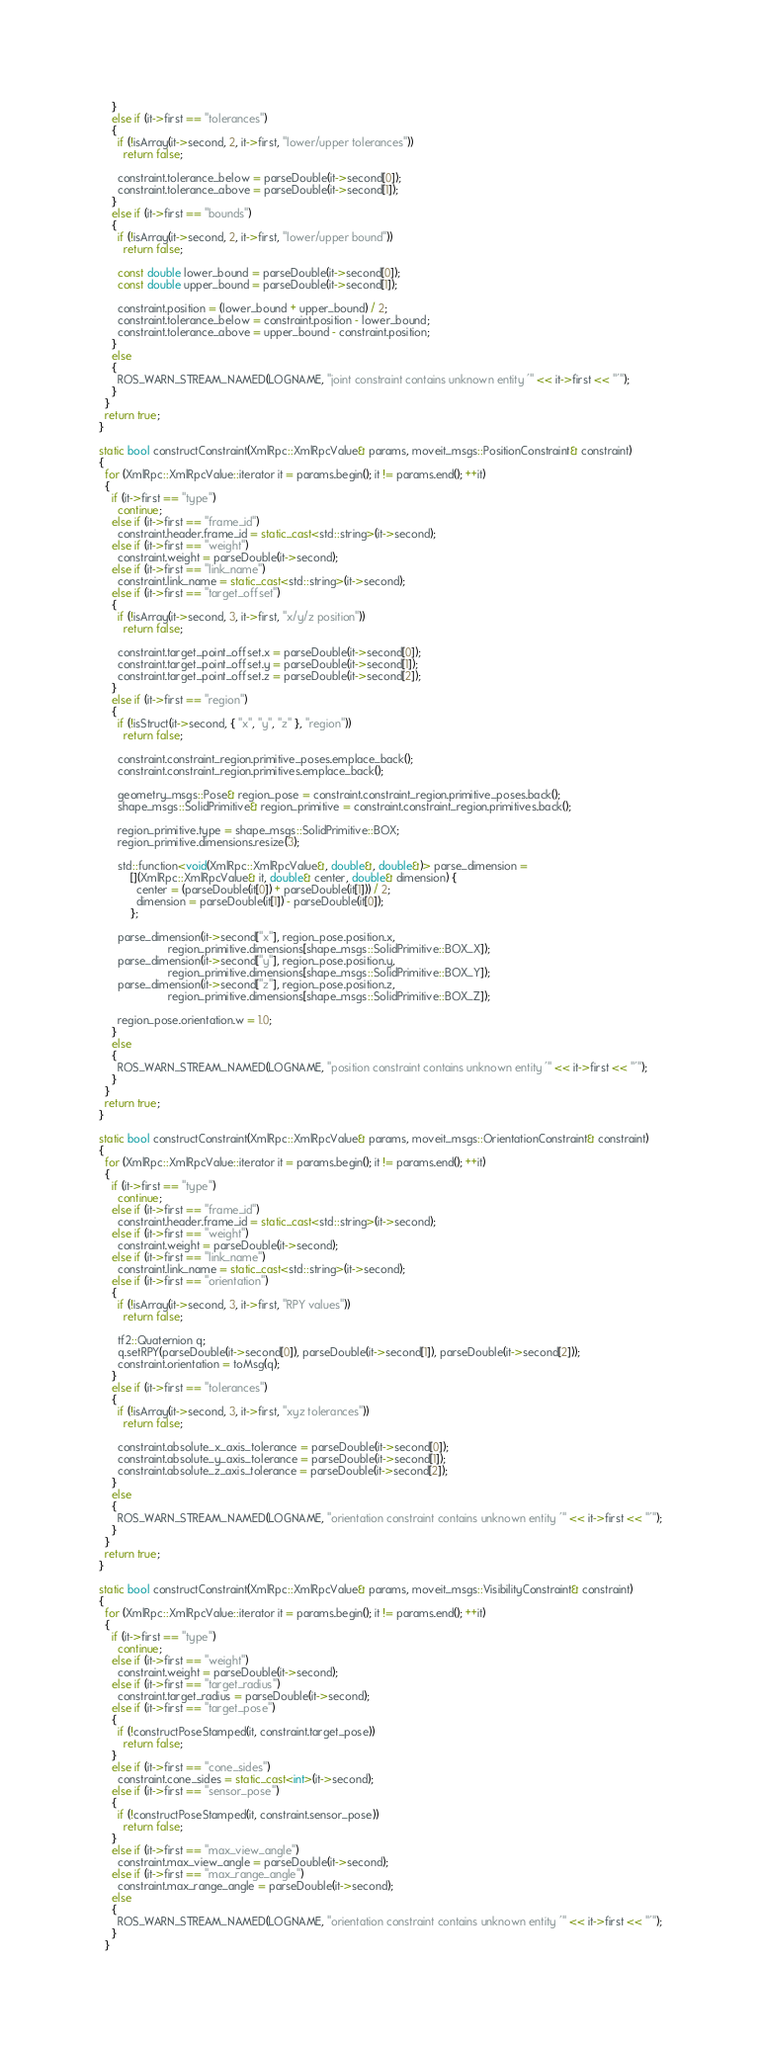Convert code to text. <code><loc_0><loc_0><loc_500><loc_500><_C++_>    }
    else if (it->first == "tolerances")
    {
      if (!isArray(it->second, 2, it->first, "lower/upper tolerances"))
        return false;

      constraint.tolerance_below = parseDouble(it->second[0]);
      constraint.tolerance_above = parseDouble(it->second[1]);
    }
    else if (it->first == "bounds")
    {
      if (!isArray(it->second, 2, it->first, "lower/upper bound"))
        return false;

      const double lower_bound = parseDouble(it->second[0]);
      const double upper_bound = parseDouble(it->second[1]);

      constraint.position = (lower_bound + upper_bound) / 2;
      constraint.tolerance_below = constraint.position - lower_bound;
      constraint.tolerance_above = upper_bound - constraint.position;
    }
    else
    {
      ROS_WARN_STREAM_NAMED(LOGNAME, "joint constraint contains unknown entity '" << it->first << "'");
    }
  }
  return true;
}

static bool constructConstraint(XmlRpc::XmlRpcValue& params, moveit_msgs::PositionConstraint& constraint)
{
  for (XmlRpc::XmlRpcValue::iterator it = params.begin(); it != params.end(); ++it)
  {
    if (it->first == "type")
      continue;
    else if (it->first == "frame_id")
      constraint.header.frame_id = static_cast<std::string>(it->second);
    else if (it->first == "weight")
      constraint.weight = parseDouble(it->second);
    else if (it->first == "link_name")
      constraint.link_name = static_cast<std::string>(it->second);
    else if (it->first == "target_offset")
    {
      if (!isArray(it->second, 3, it->first, "x/y/z position"))
        return false;

      constraint.target_point_offset.x = parseDouble(it->second[0]);
      constraint.target_point_offset.y = parseDouble(it->second[1]);
      constraint.target_point_offset.z = parseDouble(it->second[2]);
    }
    else if (it->first == "region")
    {
      if (!isStruct(it->second, { "x", "y", "z" }, "region"))
        return false;

      constraint.constraint_region.primitive_poses.emplace_back();
      constraint.constraint_region.primitives.emplace_back();

      geometry_msgs::Pose& region_pose = constraint.constraint_region.primitive_poses.back();
      shape_msgs::SolidPrimitive& region_primitive = constraint.constraint_region.primitives.back();

      region_primitive.type = shape_msgs::SolidPrimitive::BOX;
      region_primitive.dimensions.resize(3);

      std::function<void(XmlRpc::XmlRpcValue&, double&, double&)> parse_dimension =
          [](XmlRpc::XmlRpcValue& it, double& center, double& dimension) {
            center = (parseDouble(it[0]) + parseDouble(it[1])) / 2;
            dimension = parseDouble(it[1]) - parseDouble(it[0]);
          };

      parse_dimension(it->second["x"], region_pose.position.x,
                      region_primitive.dimensions[shape_msgs::SolidPrimitive::BOX_X]);
      parse_dimension(it->second["y"], region_pose.position.y,
                      region_primitive.dimensions[shape_msgs::SolidPrimitive::BOX_Y]);
      parse_dimension(it->second["z"], region_pose.position.z,
                      region_primitive.dimensions[shape_msgs::SolidPrimitive::BOX_Z]);

      region_pose.orientation.w = 1.0;
    }
    else
    {
      ROS_WARN_STREAM_NAMED(LOGNAME, "position constraint contains unknown entity '" << it->first << "'");
    }
  }
  return true;
}

static bool constructConstraint(XmlRpc::XmlRpcValue& params, moveit_msgs::OrientationConstraint& constraint)
{
  for (XmlRpc::XmlRpcValue::iterator it = params.begin(); it != params.end(); ++it)
  {
    if (it->first == "type")
      continue;
    else if (it->first == "frame_id")
      constraint.header.frame_id = static_cast<std::string>(it->second);
    else if (it->first == "weight")
      constraint.weight = parseDouble(it->second);
    else if (it->first == "link_name")
      constraint.link_name = static_cast<std::string>(it->second);
    else if (it->first == "orientation")
    {
      if (!isArray(it->second, 3, it->first, "RPY values"))
        return false;

      tf2::Quaternion q;
      q.setRPY(parseDouble(it->second[0]), parseDouble(it->second[1]), parseDouble(it->second[2]));
      constraint.orientation = toMsg(q);
    }
    else if (it->first == "tolerances")
    {
      if (!isArray(it->second, 3, it->first, "xyz tolerances"))
        return false;

      constraint.absolute_x_axis_tolerance = parseDouble(it->second[0]);
      constraint.absolute_y_axis_tolerance = parseDouble(it->second[1]);
      constraint.absolute_z_axis_tolerance = parseDouble(it->second[2]);
    }
    else
    {
      ROS_WARN_STREAM_NAMED(LOGNAME, "orientation constraint contains unknown entity '" << it->first << "'");
    }
  }
  return true;
}

static bool constructConstraint(XmlRpc::XmlRpcValue& params, moveit_msgs::VisibilityConstraint& constraint)
{
  for (XmlRpc::XmlRpcValue::iterator it = params.begin(); it != params.end(); ++it)
  {
    if (it->first == "type")
      continue;
    else if (it->first == "weight")
      constraint.weight = parseDouble(it->second);
    else if (it->first == "target_radius")
      constraint.target_radius = parseDouble(it->second);
    else if (it->first == "target_pose")
    {
      if (!constructPoseStamped(it, constraint.target_pose))
        return false;
    }
    else if (it->first == "cone_sides")
      constraint.cone_sides = static_cast<int>(it->second);
    else if (it->first == "sensor_pose")
    {
      if (!constructPoseStamped(it, constraint.sensor_pose))
        return false;
    }
    else if (it->first == "max_view_angle")
      constraint.max_view_angle = parseDouble(it->second);
    else if (it->first == "max_range_angle")
      constraint.max_range_angle = parseDouble(it->second);
    else
    {
      ROS_WARN_STREAM_NAMED(LOGNAME, "orientation constraint contains unknown entity '" << it->first << "'");
    }
  }
</code> 